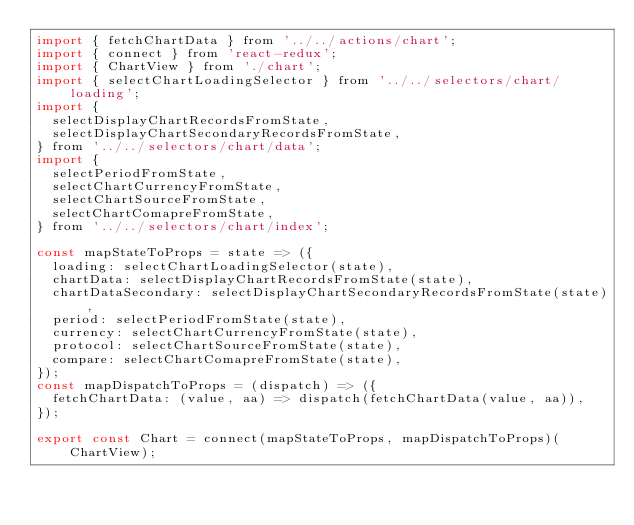<code> <loc_0><loc_0><loc_500><loc_500><_JavaScript_>import { fetchChartData } from '../../actions/chart';
import { connect } from 'react-redux';
import { ChartView } from './chart';
import { selectChartLoadingSelector } from '../../selectors/chart/loading';
import {
  selectDisplayChartRecordsFromState,
  selectDisplayChartSecondaryRecordsFromState,
} from '../../selectors/chart/data';
import {
  selectPeriodFromState,
  selectChartCurrencyFromState,
  selectChartSourceFromState,
  selectChartComapreFromState,
} from '../../selectors/chart/index';

const mapStateToProps = state => ({
  loading: selectChartLoadingSelector(state),
  chartData: selectDisplayChartRecordsFromState(state),
  chartDataSecondary: selectDisplayChartSecondaryRecordsFromState(state),
  period: selectPeriodFromState(state),
  currency: selectChartCurrencyFromState(state),
  protocol: selectChartSourceFromState(state),
  compare: selectChartComapreFromState(state),
});
const mapDispatchToProps = (dispatch) => ({
  fetchChartData: (value, aa) => dispatch(fetchChartData(value, aa)),
});

export const Chart = connect(mapStateToProps, mapDispatchToProps)(ChartView);
</code> 